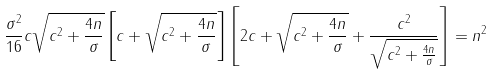<formula> <loc_0><loc_0><loc_500><loc_500>\frac { \sigma ^ { 2 } } { 1 6 } c \sqrt { c ^ { 2 } + \frac { 4 n } { \sigma } } \left [ c + \sqrt { c ^ { 2 } + \frac { 4 n } { \sigma } } \right ] \left [ 2 c + \sqrt { c ^ { 2 } + \frac { 4 n } { \sigma } } + \frac { c ^ { 2 } } { \sqrt { c ^ { 2 } + \frac { 4 n } { \sigma } } } \right ] = n ^ { 2 }</formula> 